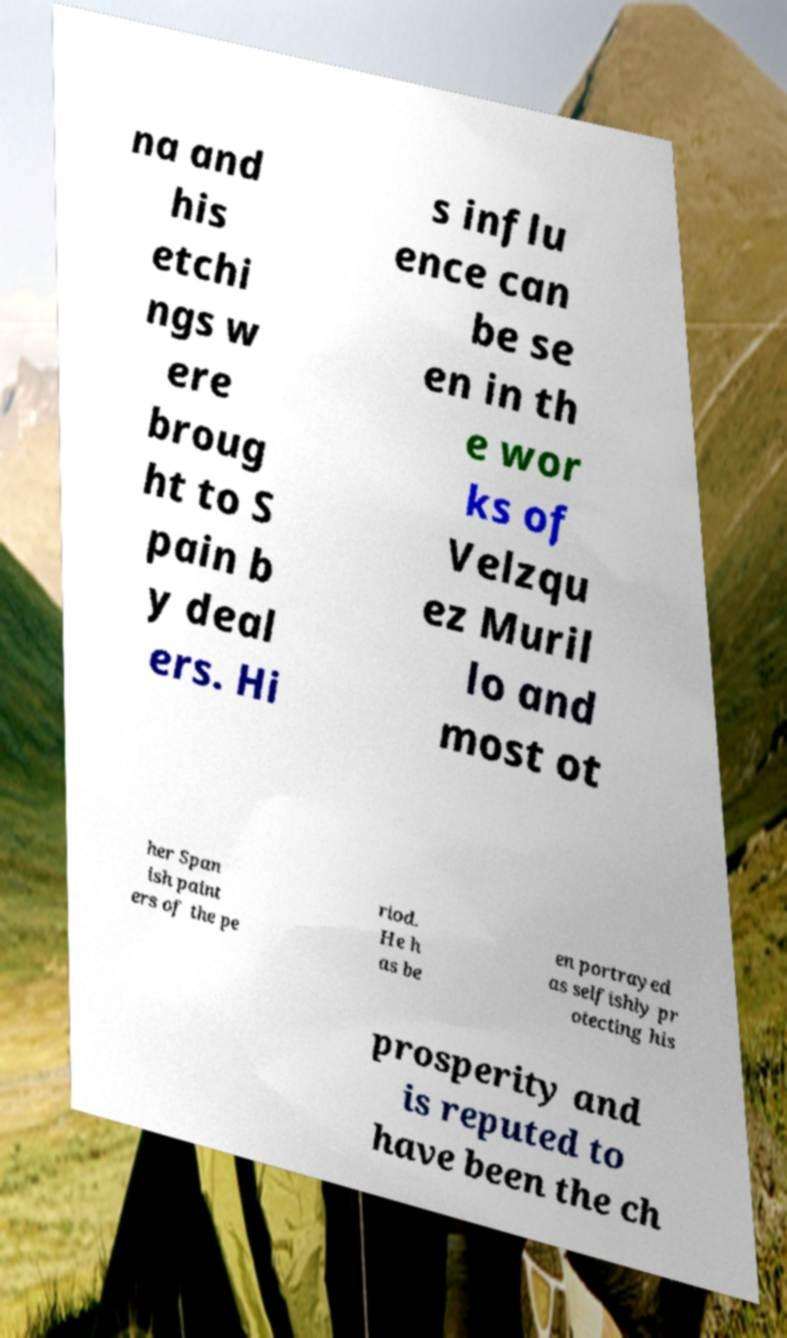There's text embedded in this image that I need extracted. Can you transcribe it verbatim? na and his etchi ngs w ere broug ht to S pain b y deal ers. Hi s influ ence can be se en in th e wor ks of Velzqu ez Muril lo and most ot her Span ish paint ers of the pe riod. He h as be en portrayed as selfishly pr otecting his prosperity and is reputed to have been the ch 